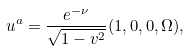<formula> <loc_0><loc_0><loc_500><loc_500>u ^ { a } = \frac { e ^ { - \nu } } { \sqrt { 1 - v ^ { 2 } } } ( 1 , 0 , 0 , \Omega ) ,</formula> 